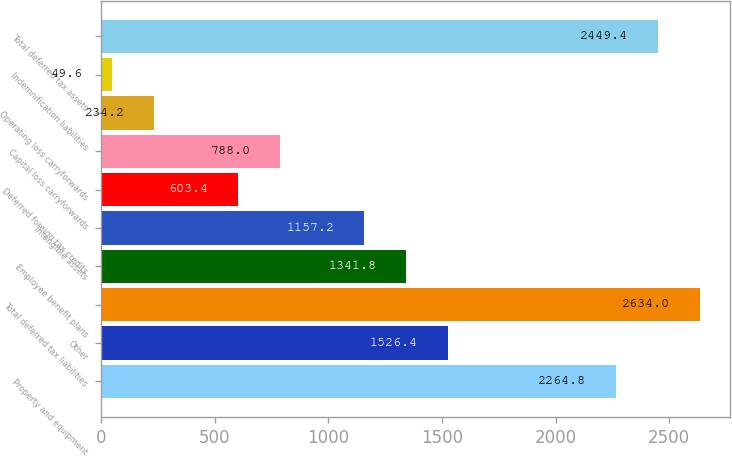Convert chart to OTSL. <chart><loc_0><loc_0><loc_500><loc_500><bar_chart><fcel>Property and equipment<fcel>Other<fcel>Total deferred tax liabilities<fcel>Employee benefit plans<fcel>Intangible assets<fcel>Deferred foreign tax credits<fcel>Capital loss carryforwards<fcel>Operating loss carryforwards<fcel>Indemnification liabilities<fcel>Total deferred tax assets<nl><fcel>2264.8<fcel>1526.4<fcel>2634<fcel>1341.8<fcel>1157.2<fcel>603.4<fcel>788<fcel>234.2<fcel>49.6<fcel>2449.4<nl></chart> 